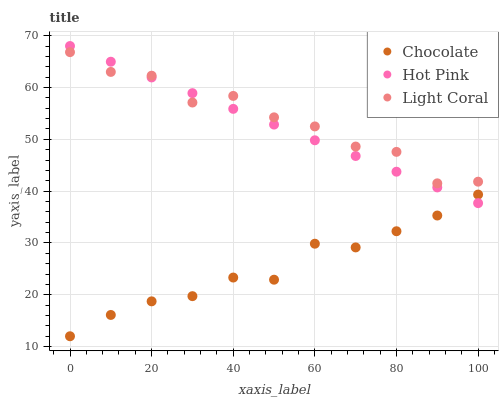Does Chocolate have the minimum area under the curve?
Answer yes or no. Yes. Does Light Coral have the maximum area under the curve?
Answer yes or no. Yes. Does Hot Pink have the minimum area under the curve?
Answer yes or no. No. Does Hot Pink have the maximum area under the curve?
Answer yes or no. No. Is Hot Pink the smoothest?
Answer yes or no. Yes. Is Light Coral the roughest?
Answer yes or no. Yes. Is Chocolate the smoothest?
Answer yes or no. No. Is Chocolate the roughest?
Answer yes or no. No. Does Chocolate have the lowest value?
Answer yes or no. Yes. Does Hot Pink have the lowest value?
Answer yes or no. No. Does Hot Pink have the highest value?
Answer yes or no. Yes. Does Chocolate have the highest value?
Answer yes or no. No. Is Chocolate less than Light Coral?
Answer yes or no. Yes. Is Light Coral greater than Chocolate?
Answer yes or no. Yes. Does Hot Pink intersect Chocolate?
Answer yes or no. Yes. Is Hot Pink less than Chocolate?
Answer yes or no. No. Is Hot Pink greater than Chocolate?
Answer yes or no. No. Does Chocolate intersect Light Coral?
Answer yes or no. No. 